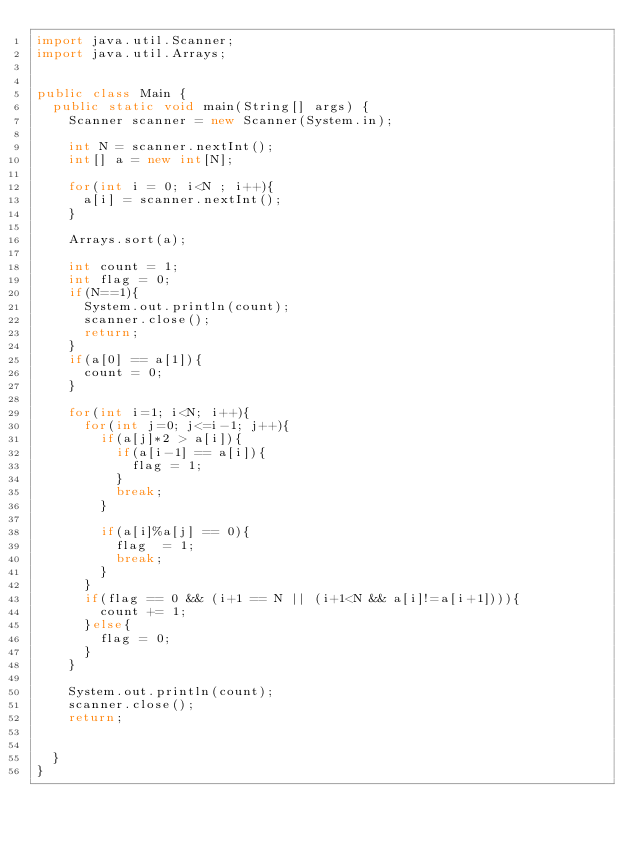<code> <loc_0><loc_0><loc_500><loc_500><_Java_>import java.util.Scanner;
import java.util.Arrays;


public class Main {
  public static void main(String[] args) {
    Scanner scanner = new Scanner(System.in);

    int N = scanner.nextInt();
    int[] a = new int[N];

    for(int i = 0; i<N ; i++){
      a[i] = scanner.nextInt();
    }

    Arrays.sort(a);
    
    int count = 1;
    int flag = 0;
    if(N==1){
      System.out.println(count);
      scanner.close();
      return;
    }
    if(a[0] == a[1]){
      count = 0;
    }

    for(int i=1; i<N; i++){
      for(int j=0; j<=i-1; j++){
        if(a[j]*2 > a[i]){
          if(a[i-1] == a[i]){
            flag = 1;
          }
          break;
        }
        
        if(a[i]%a[j] == 0){
          flag  = 1;
          break;
        }
      }
      if(flag == 0 && (i+1 == N || (i+1<N && a[i]!=a[i+1]))){
        count += 1;
      }else{
        flag = 0;
      }
    }

    System.out.println(count);
    scanner.close();
    return;
    

  }
}
</code> 